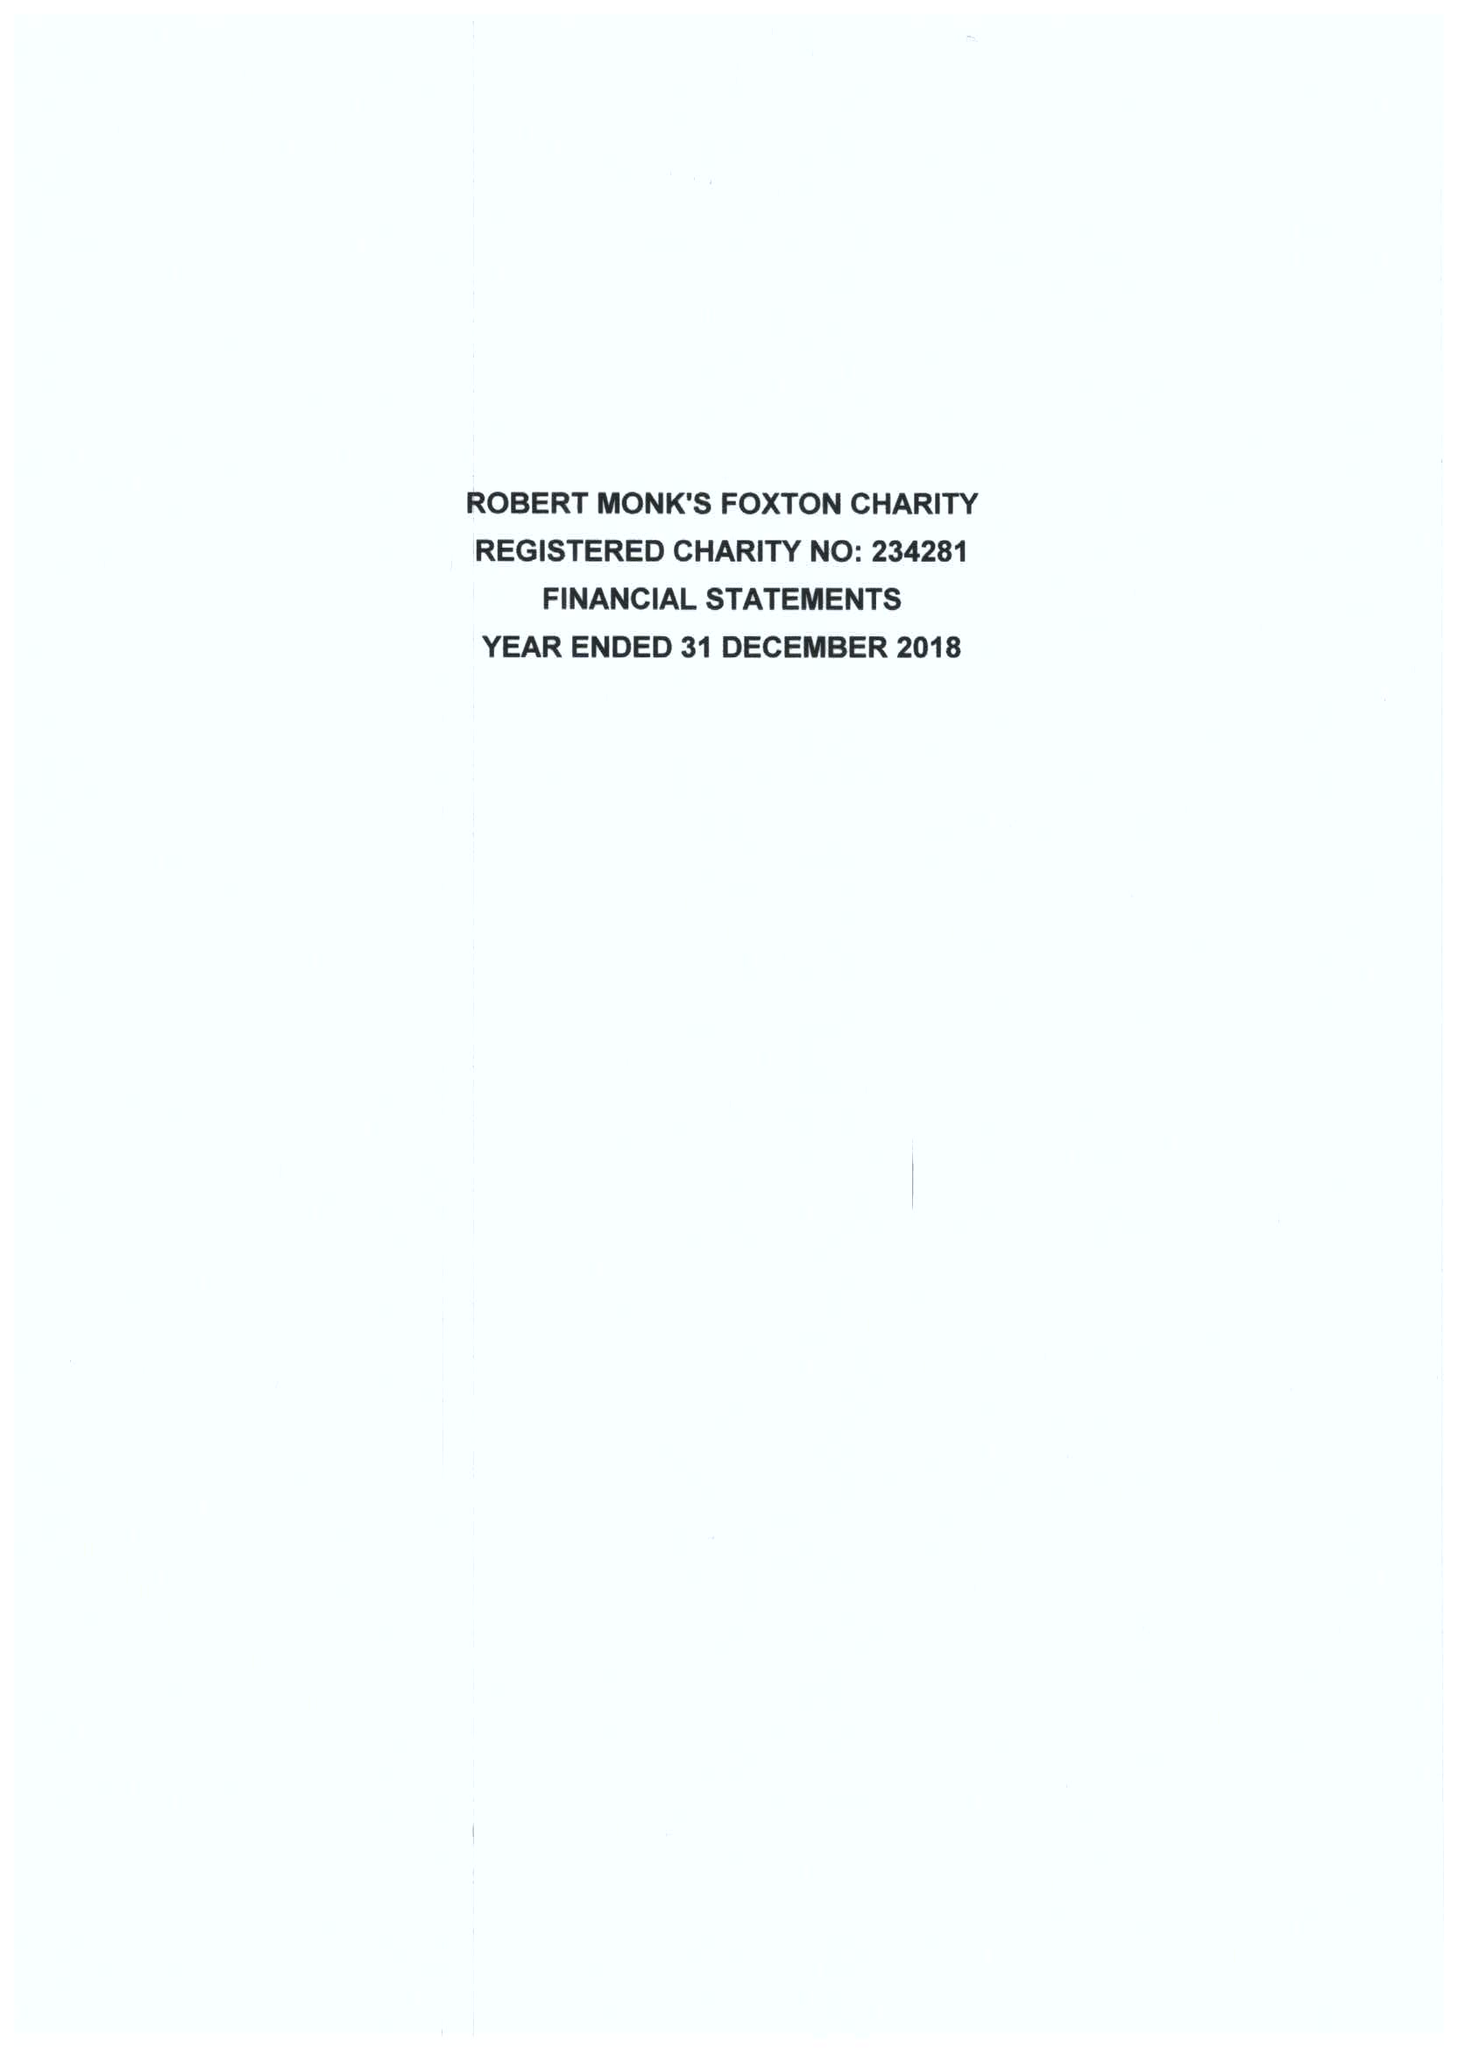What is the value for the address__street_line?
Answer the question using a single word or phrase. 49 MIDDLE STREET 